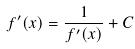Convert formula to latex. <formula><loc_0><loc_0><loc_500><loc_500>f ^ { \prime } ( x ) = \frac { 1 } { f ^ { \prime } ( x ) } + C</formula> 